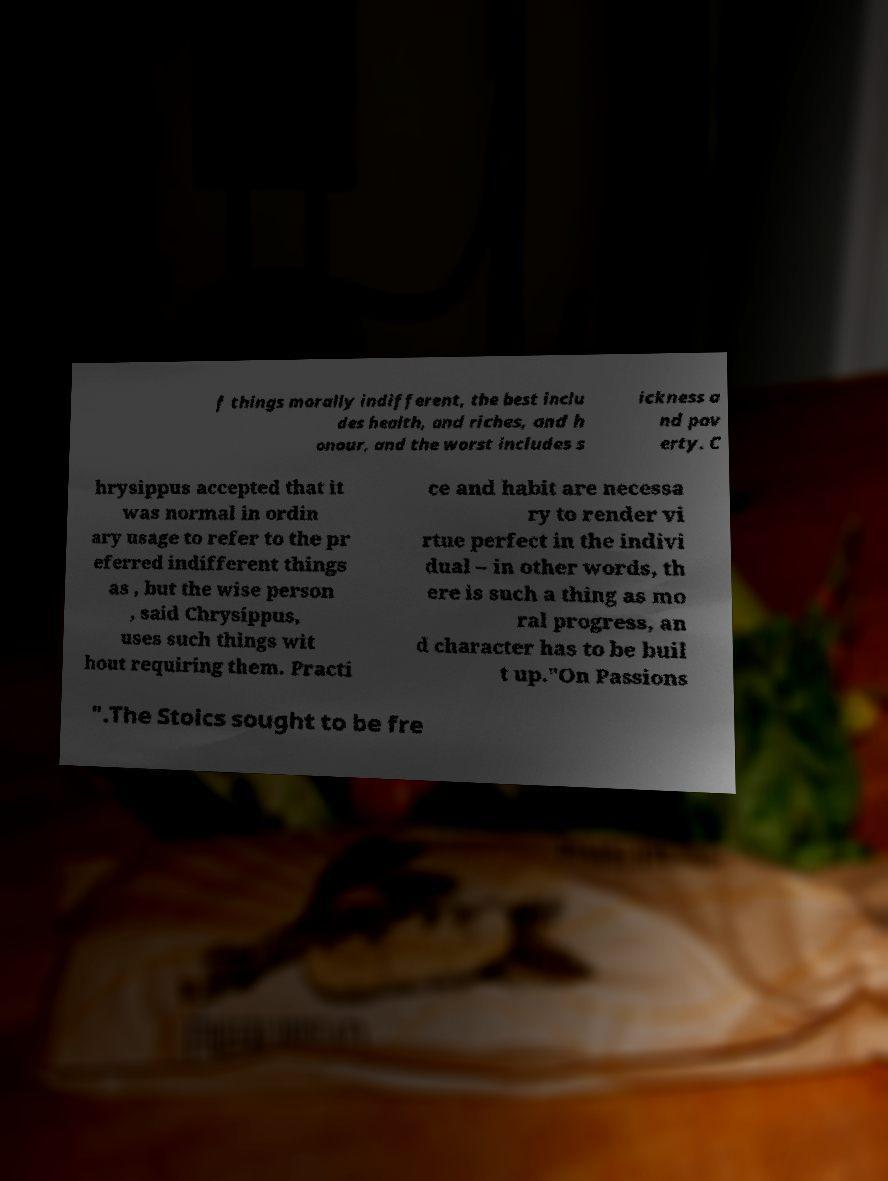Could you extract and type out the text from this image? f things morally indifferent, the best inclu des health, and riches, and h onour, and the worst includes s ickness a nd pov erty. C hrysippus accepted that it was normal in ordin ary usage to refer to the pr eferred indifferent things as , but the wise person , said Chrysippus, uses such things wit hout requiring them. Practi ce and habit are necessa ry to render vi rtue perfect in the indivi dual – in other words, th ere is such a thing as mo ral progress, an d character has to be buil t up."On Passions ".The Stoics sought to be fre 